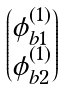<formula> <loc_0><loc_0><loc_500><loc_500>\begin{pmatrix} \phi ^ { ( 1 ) } _ { b 1 } \\ \phi ^ { ( 1 ) } _ { b 2 } \end{pmatrix}</formula> 